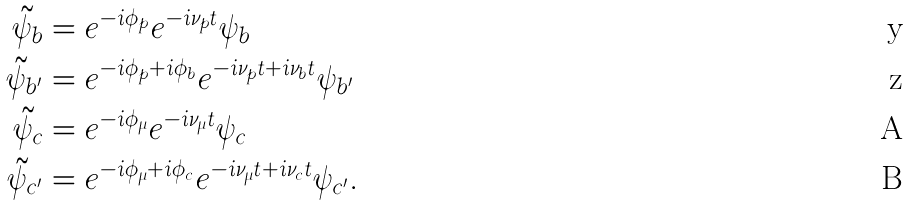Convert formula to latex. <formula><loc_0><loc_0><loc_500><loc_500>\tilde { \psi } _ { b } & = e ^ { - i \phi _ { p } } e ^ { - i \nu _ { p } t } \psi _ { b } \\ \tilde { \psi } _ { b ^ { \prime } } & = e ^ { - i \phi _ { p } + i \phi _ { b } } e ^ { - i \nu _ { p } t + i \nu _ { b } t } \psi _ { b ^ { \prime } } \\ \tilde { \psi } _ { c } & = e ^ { - i \phi _ { \mu } } e ^ { - i \nu _ { \mu } t } \psi _ { c } \\ \tilde { \psi } _ { c ^ { \prime } } & = e ^ { - i \phi _ { \mu } + i \phi _ { c } } e ^ { - i \nu _ { \mu } t + i \nu _ { c } t } \psi _ { c ^ { \prime } } .</formula> 